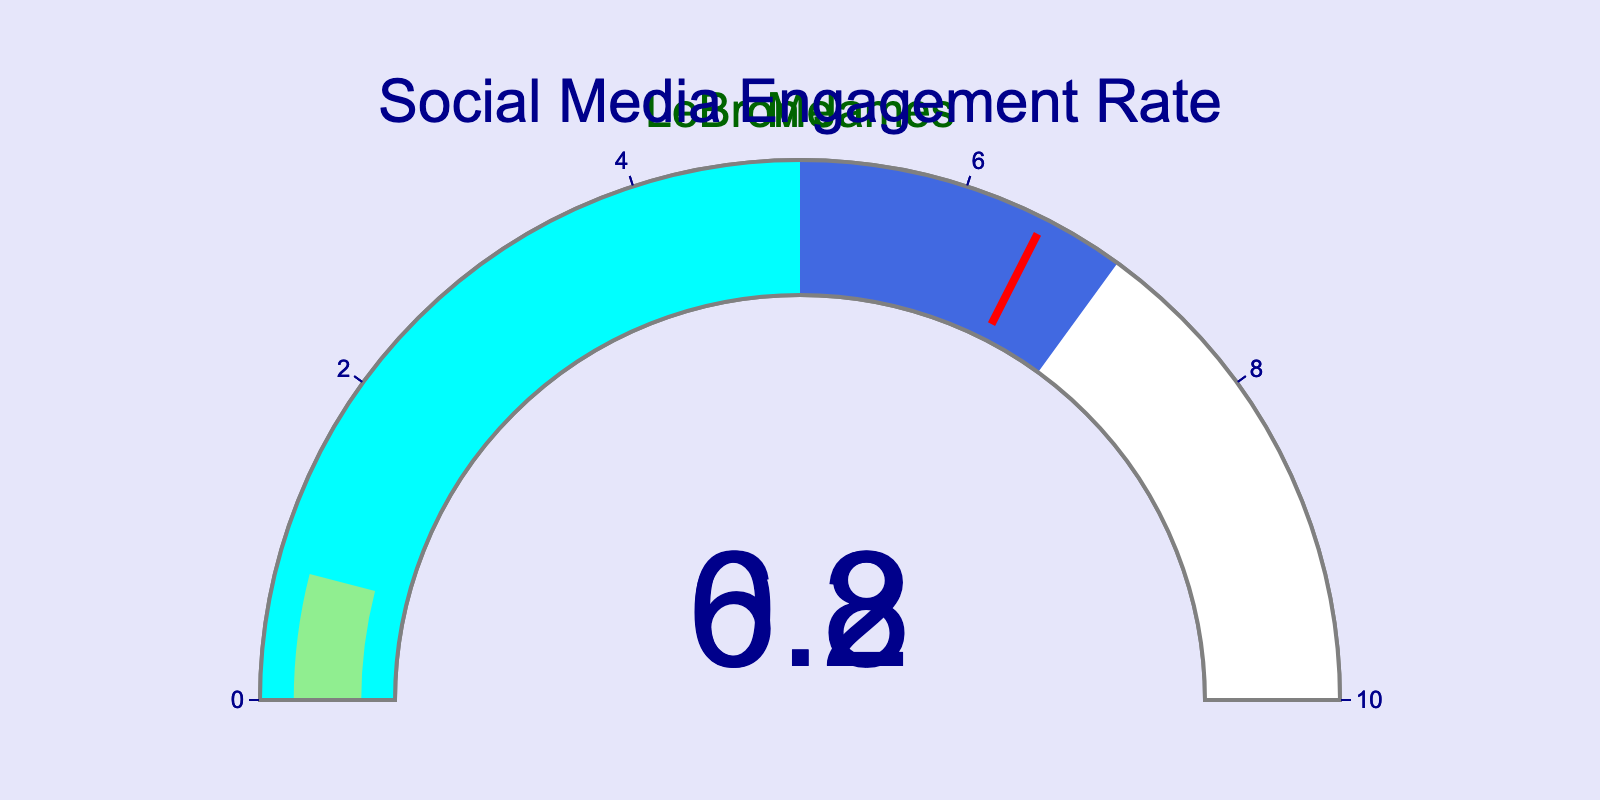what is the title of the gauge chart? The title can be easily observed at the top of the gauge chart. In this case, it should be displayed as "Social Media Engagement Rate".
Answer: Social Media Engagement Rate what is the engagement rate of LeBron James? LeBron James' engagement rate is shown directly inside the gauge chart, indicated by the number in the middle of the gauge.
Answer: 6.2 what is the engagement rate of "Me"? The engagement rate for "Me" is displayed inside the gauge chart corresponding to "Me".
Answer: 0.8 how many engagement rates are shown in the figure? The figure contains two gauge charts, one for LeBron James and one for "Me", indicating two engagement rate values.
Answer: 2 what's the difference in engagement rates between LeBron James and "Me"? To find the difference, subtract "Me"'s engagement rate from LeBron James'. That is, 6.2 - 0.8 = 5.4.
Answer: 5.4 which gauge has a higher engagement rate? Comparing the numbers displayed within the gauges, LeBron James' engagement rate is higher at 6.2 compared to "Me"'s 0.8.
Answer: LeBron James is the engagement rate of LeBron James above the threshold value depicted in the gauge? The threshold value on the gauge is set at 6.5. LeBron James' engagement rate is 6.2, which is below 6.5.
Answer: No what color signifies the range that includes "Me"s engagement rate? According to the gauge chart design, cyan color represents the range [0, 5], which includes "Me"'s engagement rate of 0.8.
Answer: Cyan in which color range does LeBron James' engagement rate fall? LeBron James' engagement rate of 6.2 falls within the range of [5, 7], which is colored royalblue on the gauge.
Answer: Royalblue what is the highest engagement rate displayed and whose rate is it? The highest engagement rate displayed is from LeBron James, with an engagement rate of 6.2, which is higher than the engagement rate of "Me".
Answer: 6.2, LeBron James 